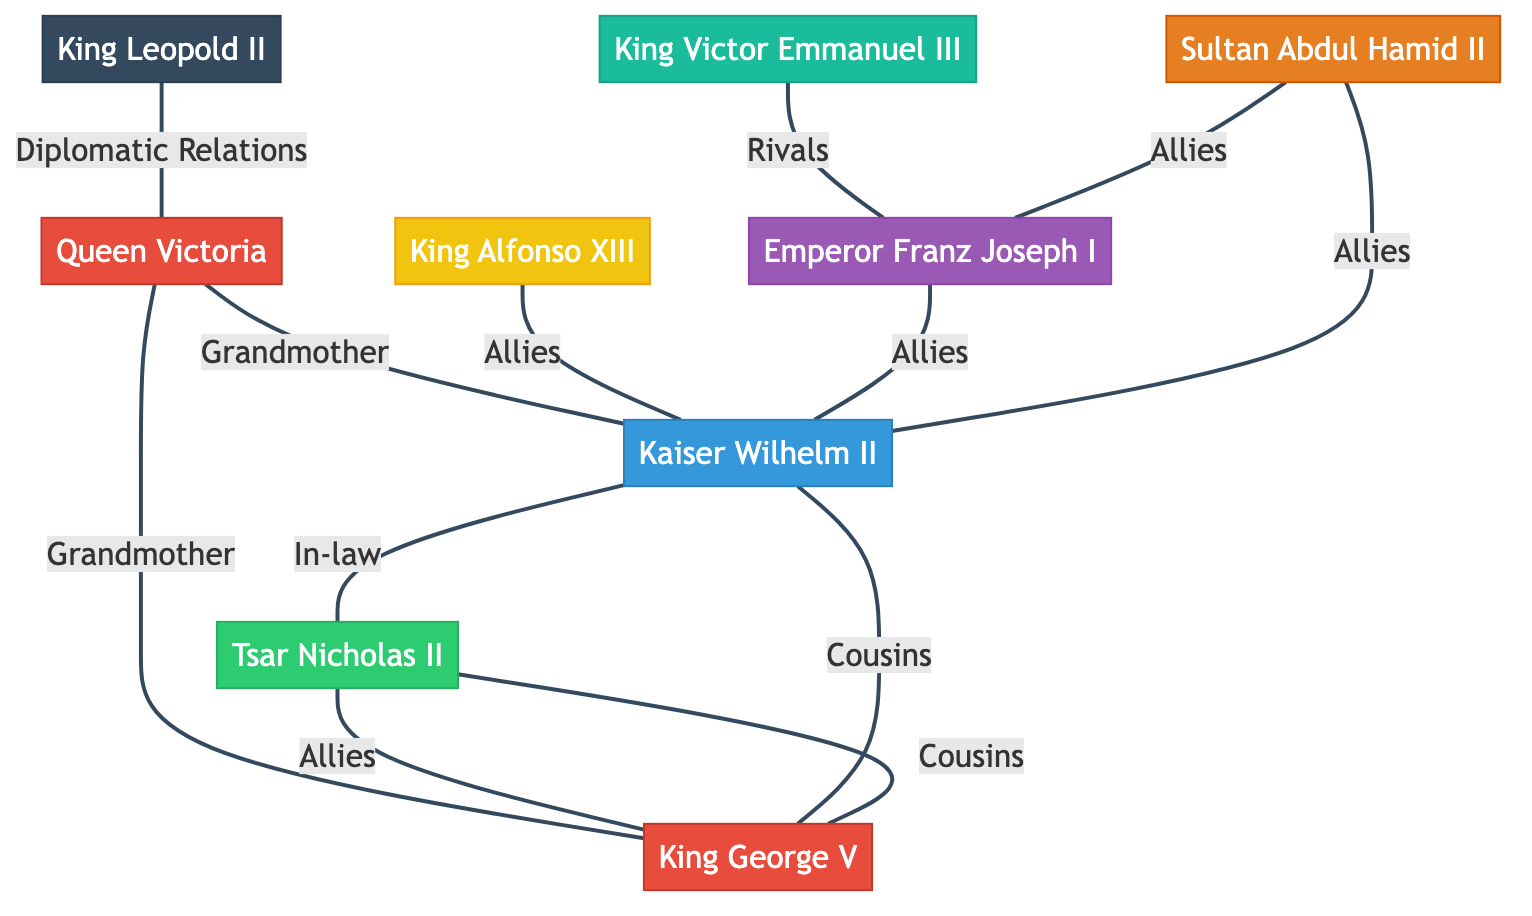What is the relationship between Queen Victoria and Kaiser Wilhelm II? The diagram indicates a direct connection labeled "Grandmother" between Queen Victoria and Kaiser Wilhelm II, meaning Queen Victoria is the grandmother of Kaiser Wilhelm II.
Answer: Grandmother How many nodes are in the diagram? The diagram contains a total of 9 nodes representing different monarchs and their countries. This is determined by counting each individual figure displayed without duplications.
Answer: 9 Who are the allies of Kaiser Wilhelm II? In the diagram, there are three arrows connecting to Kaiser Wilhelm II with the label "Allies": one connects to King Alfonso XIII, another connects to Emperor Franz Joseph I, and the last connects to Sultan Abdul Hamid II. These relationships indicate that all these monarchs are considered allies of Kaiser Wilhelm II.
Answer: King Alfonso XIII, Emperor Franz Joseph I, Sultan Abdul Hamid II What type of relationship exists between King George V and Tsar Nicholas II? The relationship between King George V and Tsar Nicholas II is indicated by the connection labeled "Cousins" in the diagram, showing a familial relationship.
Answer: Cousins How many distinct relationships are shown between Queen Victoria and other monarchs? Queen Victoria has three distinct relationships as identified in the diagram: she is a grandmother to Kaiser Wilhelm II, a grandmother to King George V, and has diplomatic relations with King Leopold II. Counting these, we find there are three different relationships shown.
Answer: 3 Which monarch is labeled as a rival to Emperor Franz Joseph I? The diagram shows an edge labeled "Rivals" connecting King Victor Emmanuel III and Emperor Franz Joseph I, indicating that King Victor Emmanuel III is identified as a rival.
Answer: King Victor Emmanuel III What is the identifier for the king from Belgium in the diagram? The diagram uses the identifier "King Leopold II" for the monarch from Belgium, represented as a node with that exact label.
Answer: King Leopold II How are Tsar Nicholas II and King George V related in terms of alliances? The diagram reveals that Tsar Nicholas II and King George V share a connection labeled "Allies", indicating a friendly diplomatic relationship between them.
Answer: Allies Which emperor is mentioned with an ally connection to Sultan Abdul Hamid II? According to the diagram, Sultan Abdul Hamid II is connected by an "Allies" relationship to Emperor Franz Joseph I. It shows that they have a mutual alliance.
Answer: Emperor Franz Joseph I 